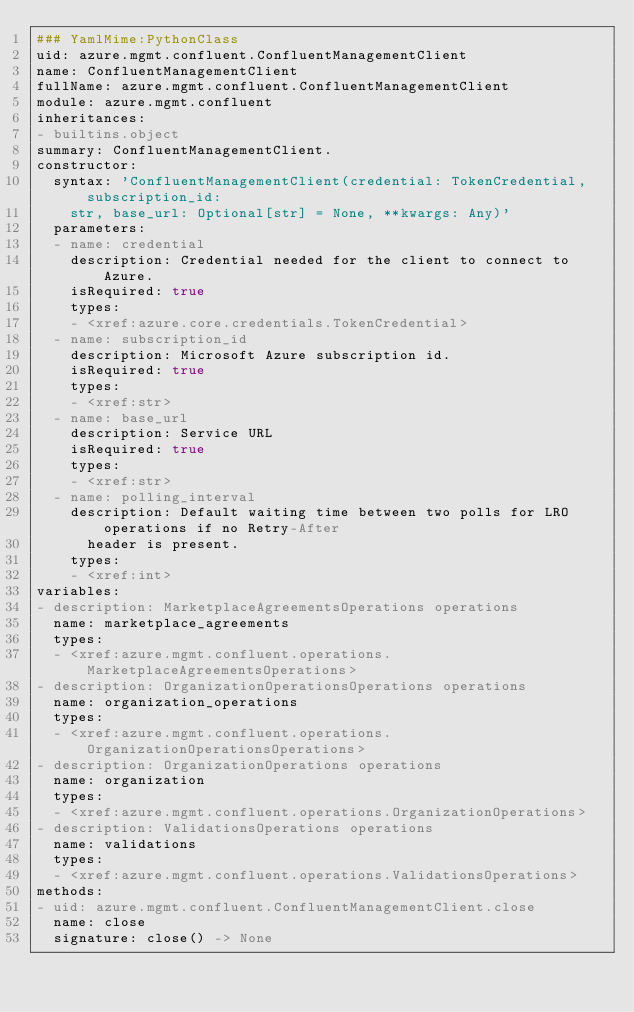<code> <loc_0><loc_0><loc_500><loc_500><_YAML_>### YamlMime:PythonClass
uid: azure.mgmt.confluent.ConfluentManagementClient
name: ConfluentManagementClient
fullName: azure.mgmt.confluent.ConfluentManagementClient
module: azure.mgmt.confluent
inheritances:
- builtins.object
summary: ConfluentManagementClient.
constructor:
  syntax: 'ConfluentManagementClient(credential: TokenCredential, subscription_id:
    str, base_url: Optional[str] = None, **kwargs: Any)'
  parameters:
  - name: credential
    description: Credential needed for the client to connect to Azure.
    isRequired: true
    types:
    - <xref:azure.core.credentials.TokenCredential>
  - name: subscription_id
    description: Microsoft Azure subscription id.
    isRequired: true
    types:
    - <xref:str>
  - name: base_url
    description: Service URL
    isRequired: true
    types:
    - <xref:str>
  - name: polling_interval
    description: Default waiting time between two polls for LRO operations if no Retry-After
      header is present.
    types:
    - <xref:int>
variables:
- description: MarketplaceAgreementsOperations operations
  name: marketplace_agreements
  types:
  - <xref:azure.mgmt.confluent.operations.MarketplaceAgreementsOperations>
- description: OrganizationOperationsOperations operations
  name: organization_operations
  types:
  - <xref:azure.mgmt.confluent.operations.OrganizationOperationsOperations>
- description: OrganizationOperations operations
  name: organization
  types:
  - <xref:azure.mgmt.confluent.operations.OrganizationOperations>
- description: ValidationsOperations operations
  name: validations
  types:
  - <xref:azure.mgmt.confluent.operations.ValidationsOperations>
methods:
- uid: azure.mgmt.confluent.ConfluentManagementClient.close
  name: close
  signature: close() -> None
</code> 